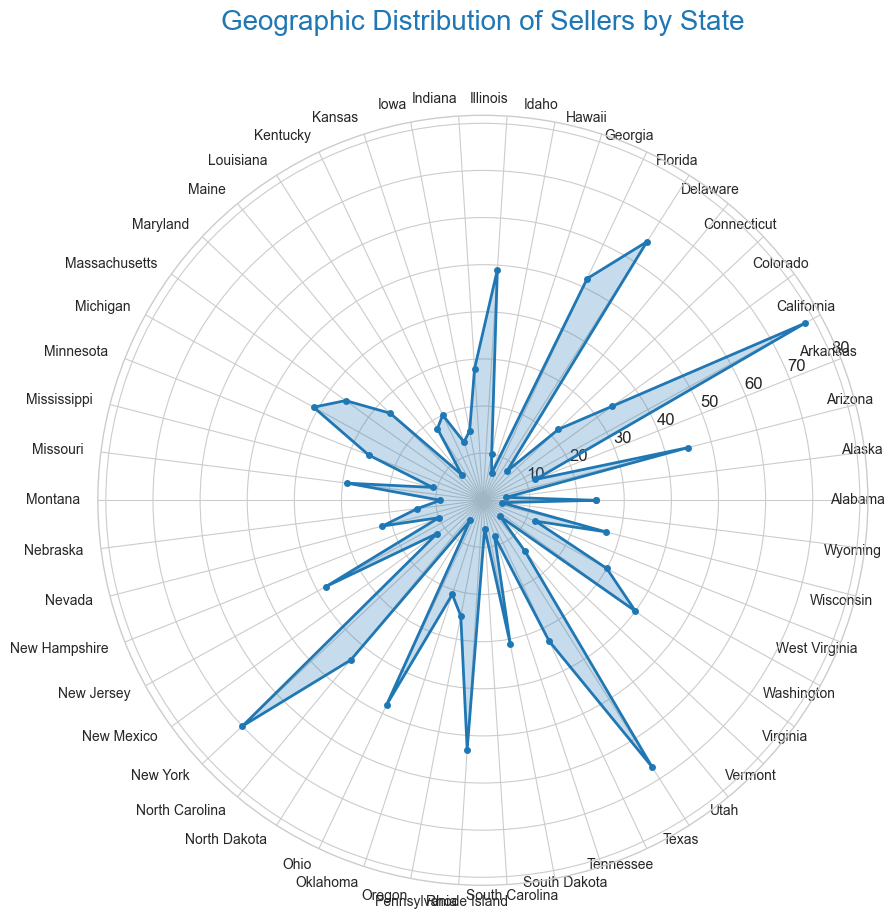What state has the highest number of sellers? By examining the lengths of the filled regions on the rose chart, the state with the longest segment indicates the highest number of sellers. California has the longest segment.
Answer: California Which states have fewer than 10 sellers? Look for the segments on the rose chart that do not extend beyond the first ring (labeled at 10). Alaska, Hawaii, Maine, Rutgers, South Dakota, and Wyoming all fall within this range.
Answer: Alaska, Hawaii, Maine, Rhode Island, South Dakota, Wyoming How many sellers are there in the states with the three largest segments? First, identify the three states with the largest segments (California, New York, Texas). Then sum the number of sellers in these states: 78 (California) + 70 (New York) + 67 (Texas) = 215.
Answer: 215 Which of North Carolina and Arizona has more sellers? Compare the lengths of the segments for North Carolina and Arizona on the chart. North Carolina's segment is slightly shorter than Arizona's.
Answer: Arizona Are there any states with exactly 20 sellers, and if so, which ones? Locate the segments that reach the line marked "20." Only Kentucky's segment reaches this exact point.
Answer: Kentucky Which state has the most sellers in the New England region (Connecticut, Maine, Massachusetts, New Hampshire, Rhode Island, Vermont)? Compare the segments for Connecticut, Maine, Massachusetts, New Hampshire, Rhode Island, and Vermont. Massachusetts has the longest segment among these states.
Answer: Massachusetts What is the difference in the number of sellers between Florida and Georgia? Determine the segment lengths for Florida and Georgia. Florida has 65 sellers and Georgia has 52 sellers. The difference is 65 - 52 = 13.
Answer: 13 How many states have more than 50 sellers? Count the segments that extend beyond the line marked "50." These states are California, Florida, Georgia, New York, Pennsylvania, and Texas. There are 6 such states.
Answer: 6 Which has more sellers, Idaho or Montana? Compare the lengths of the segments for Idaho and Montana. Idaho's segment is longer, indicating more sellers.
Answer: Idaho What are the combined sellers in Colorado, Oklahoma, and Tennessee? Sum the number of sellers for these three states: Colorado (34), Oklahoma (21), Tennessee (33). The combined number is 34 + 21 + 33 = 88.
Answer: 88 